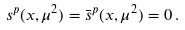Convert formula to latex. <formula><loc_0><loc_0><loc_500><loc_500>s ^ { p } ( x , \mu ^ { 2 } ) = \bar { s } ^ { p } ( x , \mu ^ { 2 } ) = 0 \, .</formula> 